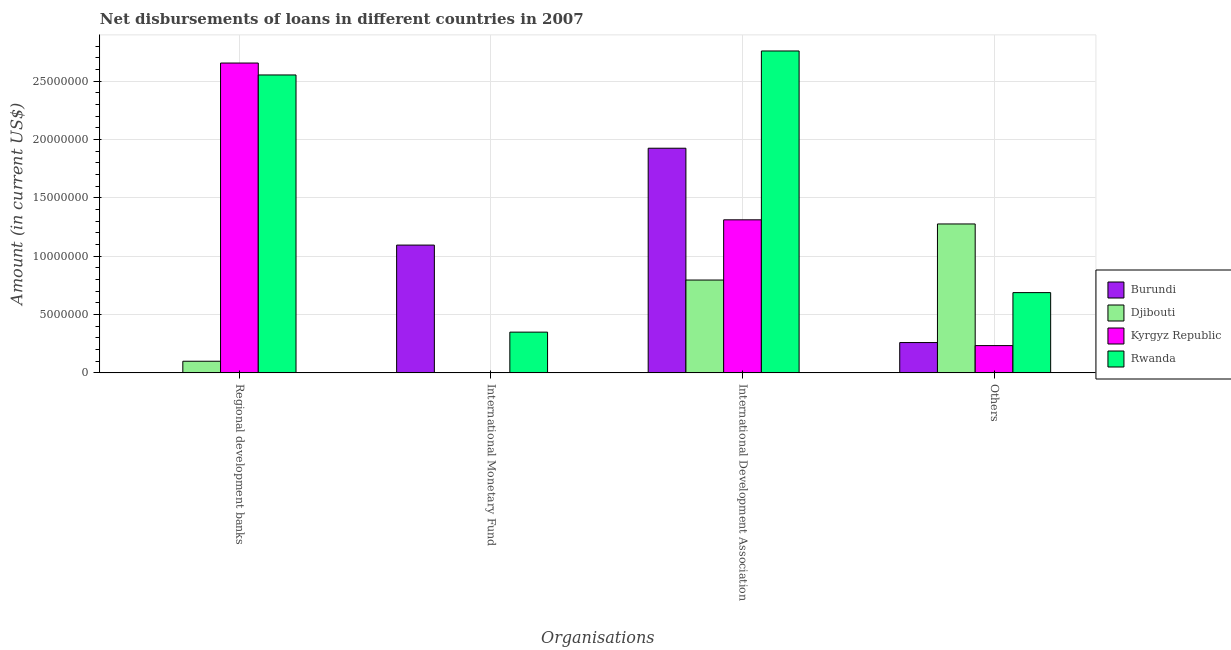How many groups of bars are there?
Provide a succinct answer. 4. How many bars are there on the 2nd tick from the left?
Keep it short and to the point. 2. How many bars are there on the 1st tick from the right?
Offer a very short reply. 4. What is the label of the 1st group of bars from the left?
Your response must be concise. Regional development banks. What is the amount of loan disimbursed by other organisations in Burundi?
Offer a terse response. 2.60e+06. Across all countries, what is the maximum amount of loan disimbursed by international development association?
Your response must be concise. 2.76e+07. Across all countries, what is the minimum amount of loan disimbursed by other organisations?
Give a very brief answer. 2.34e+06. In which country was the amount of loan disimbursed by other organisations maximum?
Ensure brevity in your answer.  Djibouti. What is the total amount of loan disimbursed by other organisations in the graph?
Ensure brevity in your answer.  2.46e+07. What is the difference between the amount of loan disimbursed by regional development banks in Djibouti and that in Kyrgyz Republic?
Provide a succinct answer. -2.55e+07. What is the difference between the amount of loan disimbursed by regional development banks in Rwanda and the amount of loan disimbursed by international monetary fund in Burundi?
Make the answer very short. 1.46e+07. What is the average amount of loan disimbursed by other organisations per country?
Offer a terse response. 6.14e+06. What is the difference between the amount of loan disimbursed by international development association and amount of loan disimbursed by international monetary fund in Rwanda?
Give a very brief answer. 2.41e+07. In how many countries, is the amount of loan disimbursed by regional development banks greater than 5000000 US$?
Give a very brief answer. 2. What is the ratio of the amount of loan disimbursed by regional development banks in Djibouti to that in Rwanda?
Your answer should be compact. 0.04. Is the difference between the amount of loan disimbursed by international development association in Rwanda and Kyrgyz Republic greater than the difference between the amount of loan disimbursed by regional development banks in Rwanda and Kyrgyz Republic?
Your answer should be compact. Yes. What is the difference between the highest and the second highest amount of loan disimbursed by other organisations?
Your response must be concise. 5.88e+06. What is the difference between the highest and the lowest amount of loan disimbursed by regional development banks?
Your answer should be very brief. 2.65e+07. In how many countries, is the amount of loan disimbursed by international development association greater than the average amount of loan disimbursed by international development association taken over all countries?
Offer a terse response. 2. Is the sum of the amount of loan disimbursed by international development association in Kyrgyz Republic and Rwanda greater than the maximum amount of loan disimbursed by international monetary fund across all countries?
Your answer should be compact. Yes. Is it the case that in every country, the sum of the amount of loan disimbursed by international monetary fund and amount of loan disimbursed by regional development banks is greater than the sum of amount of loan disimbursed by international development association and amount of loan disimbursed by other organisations?
Your answer should be very brief. No. Are all the bars in the graph horizontal?
Your response must be concise. No. How many countries are there in the graph?
Make the answer very short. 4. What is the difference between two consecutive major ticks on the Y-axis?
Make the answer very short. 5.00e+06. Does the graph contain any zero values?
Your answer should be compact. Yes. Where does the legend appear in the graph?
Provide a short and direct response. Center right. How are the legend labels stacked?
Give a very brief answer. Vertical. What is the title of the graph?
Provide a succinct answer. Net disbursements of loans in different countries in 2007. Does "Liechtenstein" appear as one of the legend labels in the graph?
Provide a short and direct response. No. What is the label or title of the X-axis?
Provide a short and direct response. Organisations. What is the label or title of the Y-axis?
Your answer should be very brief. Amount (in current US$). What is the Amount (in current US$) of Burundi in Regional development banks?
Offer a terse response. 0. What is the Amount (in current US$) in Djibouti in Regional development banks?
Keep it short and to the point. 9.96e+05. What is the Amount (in current US$) of Kyrgyz Republic in Regional development banks?
Keep it short and to the point. 2.65e+07. What is the Amount (in current US$) in Rwanda in Regional development banks?
Ensure brevity in your answer.  2.55e+07. What is the Amount (in current US$) of Burundi in International Monetary Fund?
Ensure brevity in your answer.  1.09e+07. What is the Amount (in current US$) of Kyrgyz Republic in International Monetary Fund?
Ensure brevity in your answer.  0. What is the Amount (in current US$) in Rwanda in International Monetary Fund?
Keep it short and to the point. 3.49e+06. What is the Amount (in current US$) in Burundi in International Development Association?
Give a very brief answer. 1.92e+07. What is the Amount (in current US$) in Djibouti in International Development Association?
Your response must be concise. 7.95e+06. What is the Amount (in current US$) in Kyrgyz Republic in International Development Association?
Your answer should be compact. 1.31e+07. What is the Amount (in current US$) in Rwanda in International Development Association?
Offer a terse response. 2.76e+07. What is the Amount (in current US$) in Burundi in Others?
Keep it short and to the point. 2.60e+06. What is the Amount (in current US$) of Djibouti in Others?
Give a very brief answer. 1.28e+07. What is the Amount (in current US$) in Kyrgyz Republic in Others?
Provide a short and direct response. 2.34e+06. What is the Amount (in current US$) in Rwanda in Others?
Offer a very short reply. 6.87e+06. Across all Organisations, what is the maximum Amount (in current US$) of Burundi?
Your answer should be very brief. 1.92e+07. Across all Organisations, what is the maximum Amount (in current US$) of Djibouti?
Your response must be concise. 1.28e+07. Across all Organisations, what is the maximum Amount (in current US$) in Kyrgyz Republic?
Keep it short and to the point. 2.65e+07. Across all Organisations, what is the maximum Amount (in current US$) of Rwanda?
Your answer should be very brief. 2.76e+07. Across all Organisations, what is the minimum Amount (in current US$) of Djibouti?
Your answer should be compact. 0. Across all Organisations, what is the minimum Amount (in current US$) in Kyrgyz Republic?
Your answer should be very brief. 0. Across all Organisations, what is the minimum Amount (in current US$) in Rwanda?
Provide a short and direct response. 3.49e+06. What is the total Amount (in current US$) in Burundi in the graph?
Provide a succinct answer. 3.28e+07. What is the total Amount (in current US$) of Djibouti in the graph?
Ensure brevity in your answer.  2.17e+07. What is the total Amount (in current US$) of Kyrgyz Republic in the graph?
Provide a succinct answer. 4.20e+07. What is the total Amount (in current US$) of Rwanda in the graph?
Your answer should be very brief. 6.35e+07. What is the difference between the Amount (in current US$) in Rwanda in Regional development banks and that in International Monetary Fund?
Your answer should be compact. 2.20e+07. What is the difference between the Amount (in current US$) in Djibouti in Regional development banks and that in International Development Association?
Ensure brevity in your answer.  -6.96e+06. What is the difference between the Amount (in current US$) in Kyrgyz Republic in Regional development banks and that in International Development Association?
Offer a very short reply. 1.34e+07. What is the difference between the Amount (in current US$) in Rwanda in Regional development banks and that in International Development Association?
Keep it short and to the point. -2.06e+06. What is the difference between the Amount (in current US$) of Djibouti in Regional development banks and that in Others?
Give a very brief answer. -1.18e+07. What is the difference between the Amount (in current US$) of Kyrgyz Republic in Regional development banks and that in Others?
Provide a succinct answer. 2.42e+07. What is the difference between the Amount (in current US$) in Rwanda in Regional development banks and that in Others?
Your answer should be very brief. 1.86e+07. What is the difference between the Amount (in current US$) of Burundi in International Monetary Fund and that in International Development Association?
Your answer should be very brief. -8.30e+06. What is the difference between the Amount (in current US$) in Rwanda in International Monetary Fund and that in International Development Association?
Your answer should be very brief. -2.41e+07. What is the difference between the Amount (in current US$) of Burundi in International Monetary Fund and that in Others?
Offer a terse response. 8.35e+06. What is the difference between the Amount (in current US$) of Rwanda in International Monetary Fund and that in Others?
Offer a terse response. -3.38e+06. What is the difference between the Amount (in current US$) in Burundi in International Development Association and that in Others?
Your answer should be compact. 1.66e+07. What is the difference between the Amount (in current US$) in Djibouti in International Development Association and that in Others?
Ensure brevity in your answer.  -4.80e+06. What is the difference between the Amount (in current US$) in Kyrgyz Republic in International Development Association and that in Others?
Your answer should be compact. 1.08e+07. What is the difference between the Amount (in current US$) of Rwanda in International Development Association and that in Others?
Offer a terse response. 2.07e+07. What is the difference between the Amount (in current US$) of Djibouti in Regional development banks and the Amount (in current US$) of Rwanda in International Monetary Fund?
Your answer should be compact. -2.49e+06. What is the difference between the Amount (in current US$) in Kyrgyz Republic in Regional development banks and the Amount (in current US$) in Rwanda in International Monetary Fund?
Offer a very short reply. 2.31e+07. What is the difference between the Amount (in current US$) in Djibouti in Regional development banks and the Amount (in current US$) in Kyrgyz Republic in International Development Association?
Offer a very short reply. -1.21e+07. What is the difference between the Amount (in current US$) in Djibouti in Regional development banks and the Amount (in current US$) in Rwanda in International Development Association?
Your response must be concise. -2.66e+07. What is the difference between the Amount (in current US$) of Kyrgyz Republic in Regional development banks and the Amount (in current US$) of Rwanda in International Development Association?
Your answer should be very brief. -1.03e+06. What is the difference between the Amount (in current US$) in Djibouti in Regional development banks and the Amount (in current US$) in Kyrgyz Republic in Others?
Keep it short and to the point. -1.34e+06. What is the difference between the Amount (in current US$) in Djibouti in Regional development banks and the Amount (in current US$) in Rwanda in Others?
Your response must be concise. -5.88e+06. What is the difference between the Amount (in current US$) of Kyrgyz Republic in Regional development banks and the Amount (in current US$) of Rwanda in Others?
Your answer should be compact. 1.97e+07. What is the difference between the Amount (in current US$) in Burundi in International Monetary Fund and the Amount (in current US$) in Djibouti in International Development Association?
Offer a terse response. 2.99e+06. What is the difference between the Amount (in current US$) of Burundi in International Monetary Fund and the Amount (in current US$) of Kyrgyz Republic in International Development Association?
Make the answer very short. -2.16e+06. What is the difference between the Amount (in current US$) in Burundi in International Monetary Fund and the Amount (in current US$) in Rwanda in International Development Association?
Your answer should be very brief. -1.66e+07. What is the difference between the Amount (in current US$) in Burundi in International Monetary Fund and the Amount (in current US$) in Djibouti in Others?
Offer a very short reply. -1.81e+06. What is the difference between the Amount (in current US$) in Burundi in International Monetary Fund and the Amount (in current US$) in Kyrgyz Republic in Others?
Offer a very short reply. 8.61e+06. What is the difference between the Amount (in current US$) in Burundi in International Monetary Fund and the Amount (in current US$) in Rwanda in Others?
Provide a succinct answer. 4.07e+06. What is the difference between the Amount (in current US$) in Burundi in International Development Association and the Amount (in current US$) in Djibouti in Others?
Ensure brevity in your answer.  6.49e+06. What is the difference between the Amount (in current US$) in Burundi in International Development Association and the Amount (in current US$) in Kyrgyz Republic in Others?
Keep it short and to the point. 1.69e+07. What is the difference between the Amount (in current US$) in Burundi in International Development Association and the Amount (in current US$) in Rwanda in Others?
Offer a terse response. 1.24e+07. What is the difference between the Amount (in current US$) of Djibouti in International Development Association and the Amount (in current US$) of Kyrgyz Republic in Others?
Make the answer very short. 5.62e+06. What is the difference between the Amount (in current US$) of Djibouti in International Development Association and the Amount (in current US$) of Rwanda in Others?
Provide a short and direct response. 1.08e+06. What is the difference between the Amount (in current US$) in Kyrgyz Republic in International Development Association and the Amount (in current US$) in Rwanda in Others?
Provide a succinct answer. 6.24e+06. What is the average Amount (in current US$) in Burundi per Organisations?
Ensure brevity in your answer.  8.20e+06. What is the average Amount (in current US$) of Djibouti per Organisations?
Your response must be concise. 5.43e+06. What is the average Amount (in current US$) of Kyrgyz Republic per Organisations?
Offer a very short reply. 1.05e+07. What is the average Amount (in current US$) in Rwanda per Organisations?
Ensure brevity in your answer.  1.59e+07. What is the difference between the Amount (in current US$) in Djibouti and Amount (in current US$) in Kyrgyz Republic in Regional development banks?
Offer a terse response. -2.55e+07. What is the difference between the Amount (in current US$) of Djibouti and Amount (in current US$) of Rwanda in Regional development banks?
Your answer should be compact. -2.45e+07. What is the difference between the Amount (in current US$) of Kyrgyz Republic and Amount (in current US$) of Rwanda in Regional development banks?
Offer a very short reply. 1.02e+06. What is the difference between the Amount (in current US$) of Burundi and Amount (in current US$) of Rwanda in International Monetary Fund?
Give a very brief answer. 7.46e+06. What is the difference between the Amount (in current US$) in Burundi and Amount (in current US$) in Djibouti in International Development Association?
Ensure brevity in your answer.  1.13e+07. What is the difference between the Amount (in current US$) of Burundi and Amount (in current US$) of Kyrgyz Republic in International Development Association?
Make the answer very short. 6.13e+06. What is the difference between the Amount (in current US$) of Burundi and Amount (in current US$) of Rwanda in International Development Association?
Keep it short and to the point. -8.33e+06. What is the difference between the Amount (in current US$) of Djibouti and Amount (in current US$) of Kyrgyz Republic in International Development Association?
Provide a short and direct response. -5.16e+06. What is the difference between the Amount (in current US$) of Djibouti and Amount (in current US$) of Rwanda in International Development Association?
Your answer should be compact. -1.96e+07. What is the difference between the Amount (in current US$) of Kyrgyz Republic and Amount (in current US$) of Rwanda in International Development Association?
Offer a terse response. -1.45e+07. What is the difference between the Amount (in current US$) of Burundi and Amount (in current US$) of Djibouti in Others?
Give a very brief answer. -1.02e+07. What is the difference between the Amount (in current US$) in Burundi and Amount (in current US$) in Kyrgyz Republic in Others?
Provide a succinct answer. 2.61e+05. What is the difference between the Amount (in current US$) of Burundi and Amount (in current US$) of Rwanda in Others?
Provide a short and direct response. -4.28e+06. What is the difference between the Amount (in current US$) in Djibouti and Amount (in current US$) in Kyrgyz Republic in Others?
Make the answer very short. 1.04e+07. What is the difference between the Amount (in current US$) in Djibouti and Amount (in current US$) in Rwanda in Others?
Your answer should be compact. 5.88e+06. What is the difference between the Amount (in current US$) of Kyrgyz Republic and Amount (in current US$) of Rwanda in Others?
Provide a succinct answer. -4.54e+06. What is the ratio of the Amount (in current US$) of Rwanda in Regional development banks to that in International Monetary Fund?
Provide a short and direct response. 7.31. What is the ratio of the Amount (in current US$) of Djibouti in Regional development banks to that in International Development Association?
Your answer should be very brief. 0.13. What is the ratio of the Amount (in current US$) of Kyrgyz Republic in Regional development banks to that in International Development Association?
Your response must be concise. 2.02. What is the ratio of the Amount (in current US$) in Rwanda in Regional development banks to that in International Development Association?
Offer a terse response. 0.93. What is the ratio of the Amount (in current US$) of Djibouti in Regional development banks to that in Others?
Ensure brevity in your answer.  0.08. What is the ratio of the Amount (in current US$) of Kyrgyz Republic in Regional development banks to that in Others?
Keep it short and to the point. 11.37. What is the ratio of the Amount (in current US$) of Rwanda in Regional development banks to that in Others?
Your response must be concise. 3.71. What is the ratio of the Amount (in current US$) of Burundi in International Monetary Fund to that in International Development Association?
Provide a short and direct response. 0.57. What is the ratio of the Amount (in current US$) in Rwanda in International Monetary Fund to that in International Development Association?
Offer a very short reply. 0.13. What is the ratio of the Amount (in current US$) of Burundi in International Monetary Fund to that in Others?
Make the answer very short. 4.22. What is the ratio of the Amount (in current US$) of Rwanda in International Monetary Fund to that in Others?
Offer a very short reply. 0.51. What is the ratio of the Amount (in current US$) of Burundi in International Development Association to that in Others?
Your answer should be very brief. 7.41. What is the ratio of the Amount (in current US$) in Djibouti in International Development Association to that in Others?
Give a very brief answer. 0.62. What is the ratio of the Amount (in current US$) of Kyrgyz Republic in International Development Association to that in Others?
Give a very brief answer. 5.62. What is the ratio of the Amount (in current US$) of Rwanda in International Development Association to that in Others?
Your answer should be compact. 4.01. What is the difference between the highest and the second highest Amount (in current US$) of Burundi?
Keep it short and to the point. 8.30e+06. What is the difference between the highest and the second highest Amount (in current US$) in Djibouti?
Offer a terse response. 4.80e+06. What is the difference between the highest and the second highest Amount (in current US$) in Kyrgyz Republic?
Provide a short and direct response. 1.34e+07. What is the difference between the highest and the second highest Amount (in current US$) of Rwanda?
Provide a succinct answer. 2.06e+06. What is the difference between the highest and the lowest Amount (in current US$) in Burundi?
Provide a succinct answer. 1.92e+07. What is the difference between the highest and the lowest Amount (in current US$) in Djibouti?
Offer a terse response. 1.28e+07. What is the difference between the highest and the lowest Amount (in current US$) of Kyrgyz Republic?
Provide a succinct answer. 2.65e+07. What is the difference between the highest and the lowest Amount (in current US$) in Rwanda?
Offer a very short reply. 2.41e+07. 